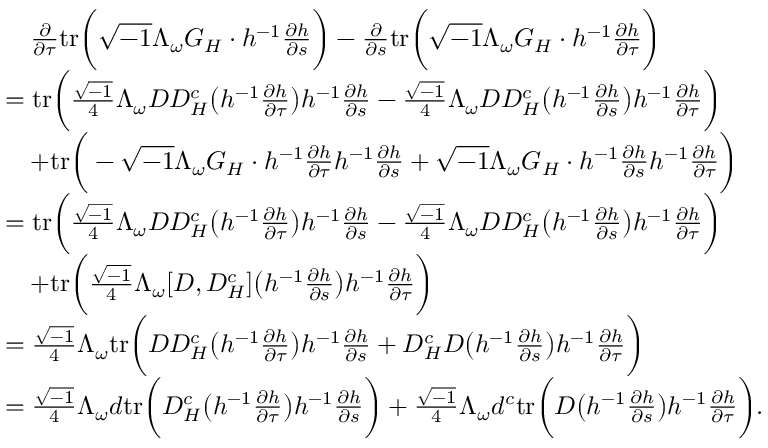<formula> <loc_0><loc_0><loc_500><loc_500>\begin{array} { r l } & { \quad \frac { \partial } { \partial \tau } t r \left ( \sqrt { - 1 } \Lambda _ { \omega } G _ { H } \cdot h ^ { - 1 } \frac { \partial h } { \partial s } \right ) - \frac { \partial } { \partial s } t r \left ( \sqrt { - 1 } \Lambda _ { \omega } G _ { H } \cdot h ^ { - 1 } \frac { \partial h } { \partial \tau } \right ) } \\ & { = t r \left ( \frac { \sqrt { - 1 } } { 4 } \Lambda _ { \omega } D D _ { H } ^ { c } \left ( h ^ { - 1 } \frac { \partial h } { \partial \tau } \right ) h ^ { - 1 } \frac { \partial h } { \partial s } - \frac { \sqrt { - 1 } } { 4 } \Lambda _ { \omega } D D _ { H } ^ { c } \left ( h ^ { - 1 } \frac { \partial h } { \partial s } \right ) h ^ { - 1 } \frac { \partial h } { \partial \tau } \right ) } \\ & { \quad + t r \left ( - \sqrt { - 1 } \Lambda _ { \omega } G _ { H } \cdot h ^ { - 1 } \frac { \partial h } { \partial \tau } h ^ { - 1 } \frac { \partial h } { \partial s } + \sqrt { - 1 } \Lambda _ { \omega } G _ { H } \cdot h ^ { - 1 } \frac { \partial h } { \partial s } h ^ { - 1 } \frac { \partial h } { \partial \tau } \right ) } \\ & { = t r \left ( \frac { \sqrt { - 1 } } { 4 } \Lambda _ { \omega } D D _ { H } ^ { c } \left ( h ^ { - 1 } \frac { \partial h } { \partial \tau } \right ) h ^ { - 1 } \frac { \partial h } { \partial s } - \frac { \sqrt { - 1 } } { 4 } \Lambda _ { \omega } D D _ { H } ^ { c } \left ( h ^ { - 1 } \frac { \partial h } { \partial s } \right ) h ^ { - 1 } \frac { \partial h } { \partial \tau } \right ) } \\ & { \quad + t r \left ( \frac { \sqrt { - 1 } } { 4 } \Lambda _ { \omega } [ D , D _ { H } ^ { c } ] \left ( h ^ { - 1 } \frac { \partial h } { \partial s } \right ) h ^ { - 1 } \frac { \partial h } { \partial \tau } \right ) } \\ & { = \frac { \sqrt { - 1 } } { 4 } \Lambda _ { \omega } t r \left ( D D _ { H } ^ { c } \left ( h ^ { - 1 } \frac { \partial h } { \partial \tau } \right ) h ^ { - 1 } \frac { \partial h } { \partial s } + D _ { H } ^ { c } D \left ( h ^ { - 1 } \frac { \partial h } { \partial s } \right ) h ^ { - 1 } \frac { \partial h } { \partial \tau } \right ) } \\ & { = \frac { \sqrt { - 1 } } { 4 } \Lambda _ { \omega } d t r \left ( D _ { H } ^ { c } \left ( h ^ { - 1 } \frac { \partial h } { \partial \tau } \right ) h ^ { - 1 } \frac { \partial h } { \partial s } \right ) + \frac { \sqrt { - 1 } } { 4 } \Lambda _ { \omega } d ^ { c } t r \left ( D \left ( h ^ { - 1 } \frac { \partial h } { \partial s } \right ) h ^ { - 1 } \frac { \partial h } { \partial \tau } \right ) . } \end{array}</formula> 